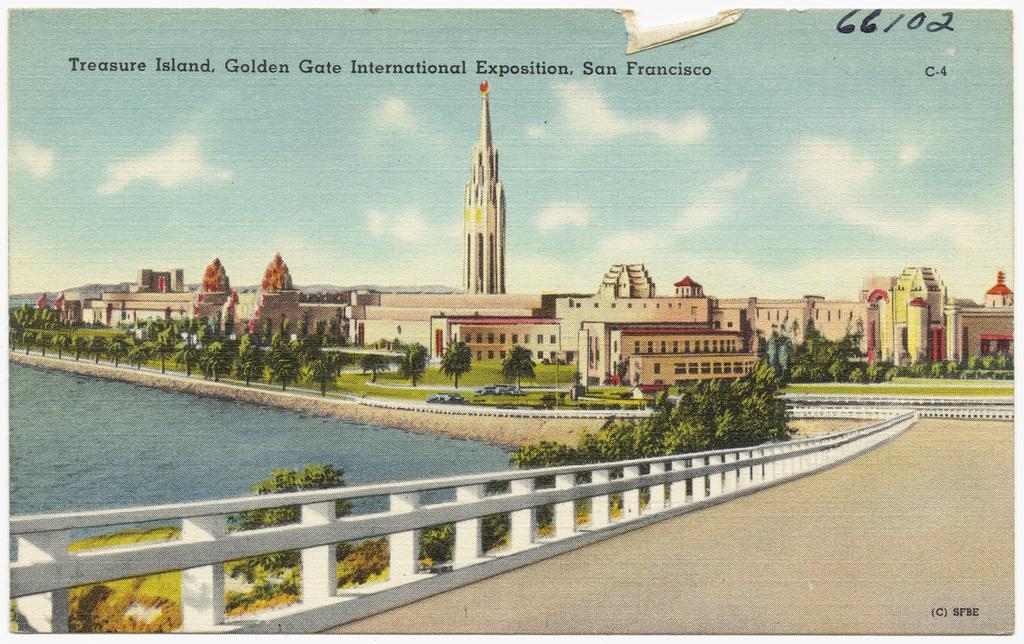Describe this image in one or two sentences. This is an edited image. In the foreground we can see the ground and the metal fence and we can see a water body, grass, plants and trees. In the center we can see the buildings and a tower. In the background there is a sky. At the top there is a text on the image. 